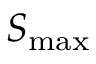<formula> <loc_0><loc_0><loc_500><loc_500>S _ { \max }</formula> 